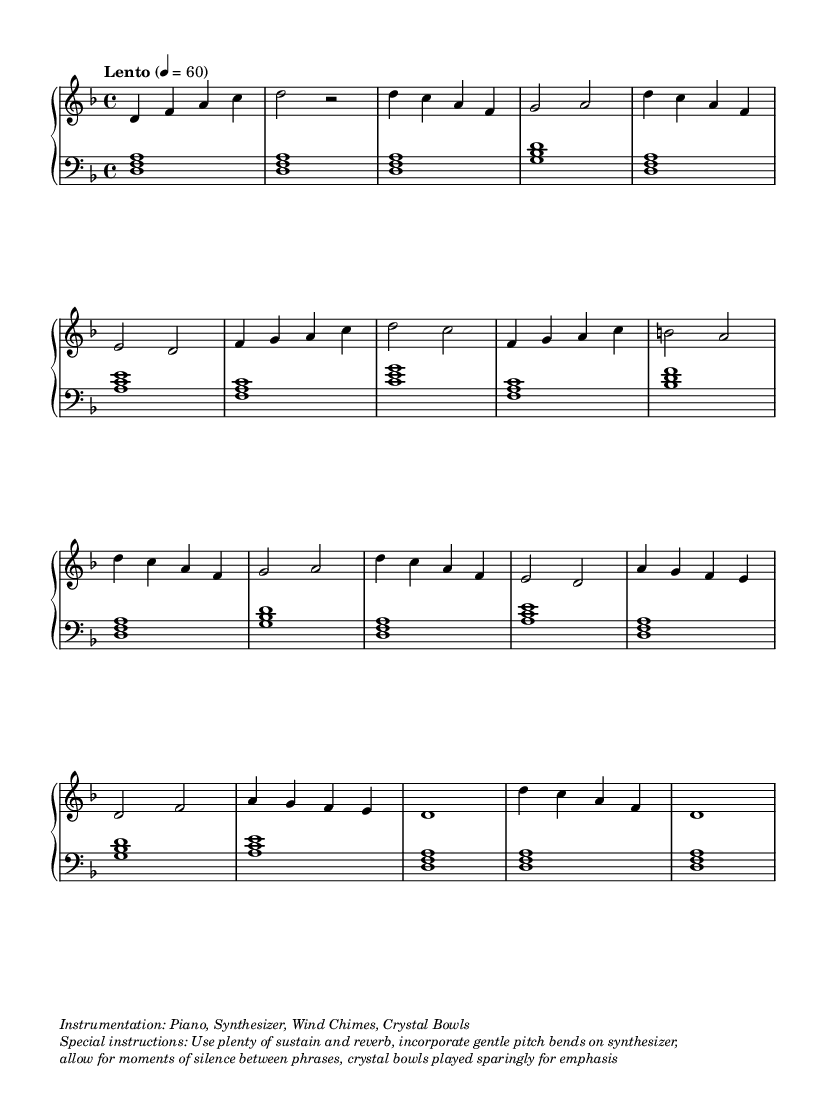What is the key signature of this music? The key signature is indicated by the symbols next to the clef at the beginning of the staff. In this case, there are one flat (B) shown, which indicates the key of D minor.
Answer: D minor What is the time signature of this piece? The time signature is located right after the key signature and indicates how many beats are in each measure. Here, the notation shows a 4 over 4, meaning there are four beats in each measure.
Answer: 4/4 What is the tempo marking for this music? The tempo marking is found at the beginning above the staff, stating "Lento," which means slow. It also specifies the exact beats per minute (60), indicating the pace of the piece.
Answer: Lento How many distinct sections are in this composition? To determine the number of sections, one can examine the labels and patterns in the music. The letters A, B, and C indicate different sections, and since A is repeated, there are actually three distinct sections.
Answer: 3 What is the primary instrumentation indicated for the performance? The instrumentation is provided in the markup at the end of the code. It specifically lists the instruments used in this composition. The mention of Piano, Synthesizer, Wind Chimes, and Crystal Bowls implies the blending of these sounds to create a unique atmosphere.
Answer: Piano, Synthesizer, Wind Chimes, Crystal Bowls What kind of musical techniques are suggested for this piece? The specific performance techniques are described in the markup sections at the end of the code, stating to use plenty of sustain and reverb, gentle pitch bends on the synthesizer, and moments of silence between phrases, which enhance the ethereal quality of the music.
Answer: Sustain, reverb, pitch bends How is silence incorporated into the music? Silence is implied in the structure of the piece, illustrated by the use of rests and instructions for moments of silence between phrases, which allows the music to breathe and creates a more meditative atmosphere.
Answer: Moments of silence 